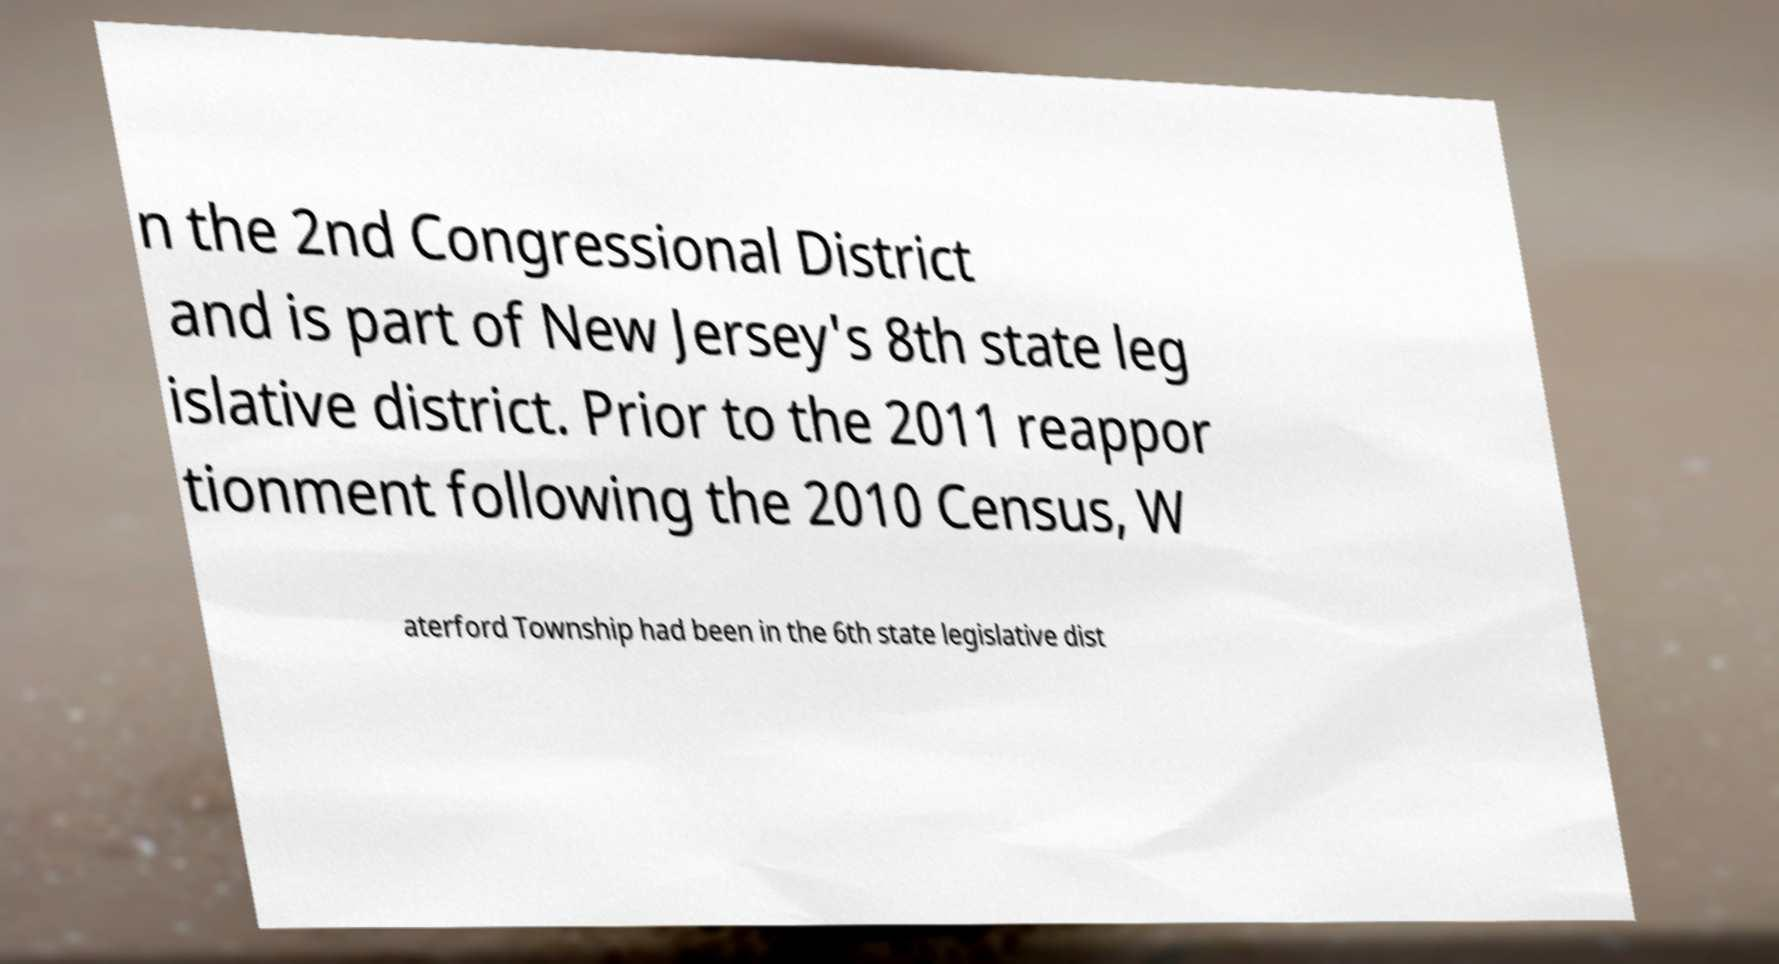Could you extract and type out the text from this image? n the 2nd Congressional District and is part of New Jersey's 8th state leg islative district. Prior to the 2011 reappor tionment following the 2010 Census, W aterford Township had been in the 6th state legislative dist 